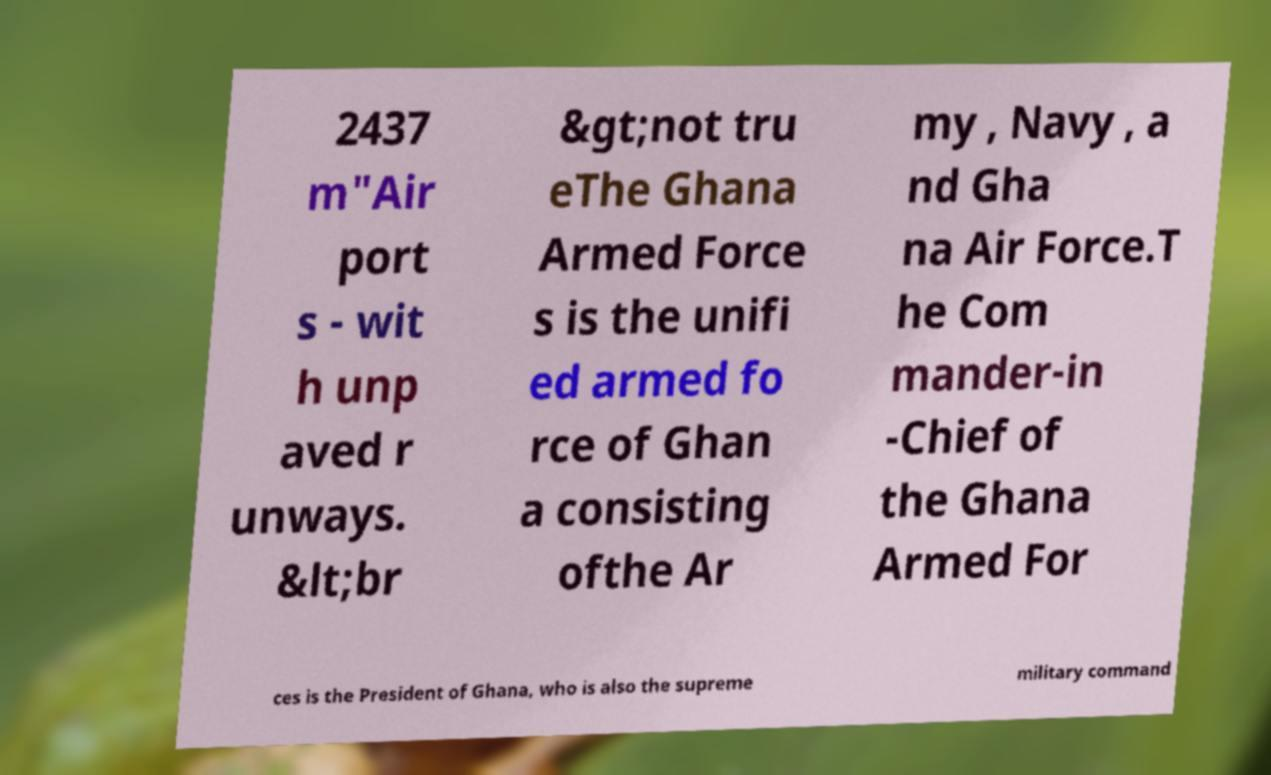For documentation purposes, I need the text within this image transcribed. Could you provide that? 2437 m"Air port s - wit h unp aved r unways. &lt;br &gt;not tru eThe Ghana Armed Force s is the unifi ed armed fo rce of Ghan a consisting ofthe Ar my , Navy , a nd Gha na Air Force.T he Com mander-in -Chief of the Ghana Armed For ces is the President of Ghana, who is also the supreme military command 